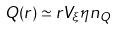Convert formula to latex. <formula><loc_0><loc_0><loc_500><loc_500>Q ( r ) \simeq r V _ { \xi } \eta n _ { Q }</formula> 